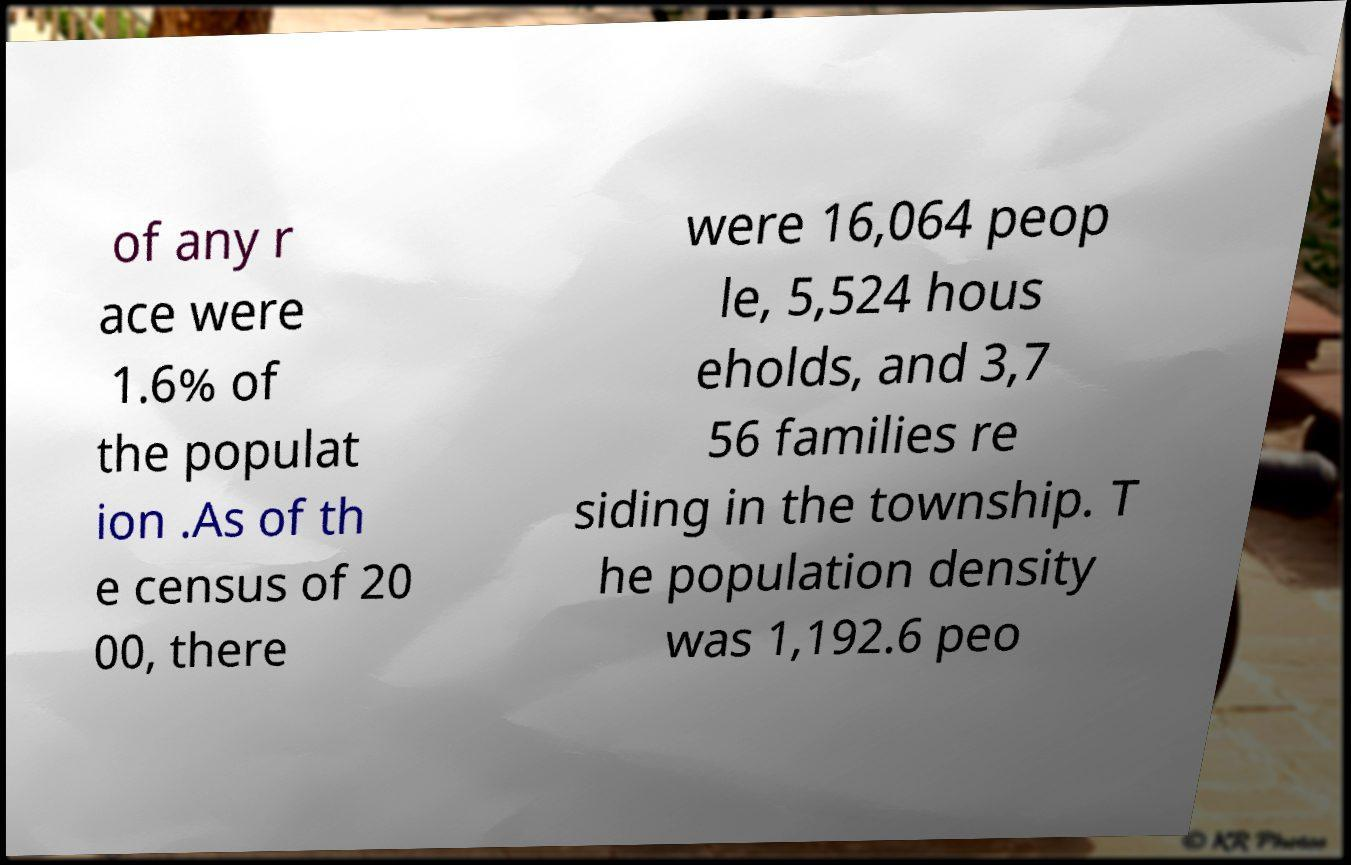I need the written content from this picture converted into text. Can you do that? of any r ace were 1.6% of the populat ion .As of th e census of 20 00, there were 16,064 peop le, 5,524 hous eholds, and 3,7 56 families re siding in the township. T he population density was 1,192.6 peo 